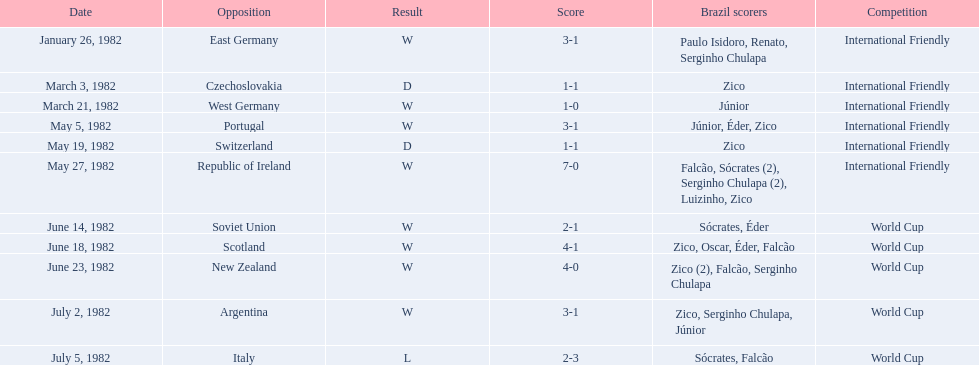What was the number of goals brazil scored when they played against the soviet union? 2-1. What was the number of goals brazil scored when they played against portugal? 3-1. Which team did brazil score more goals against, portugal or the soviet union? Portugal. 